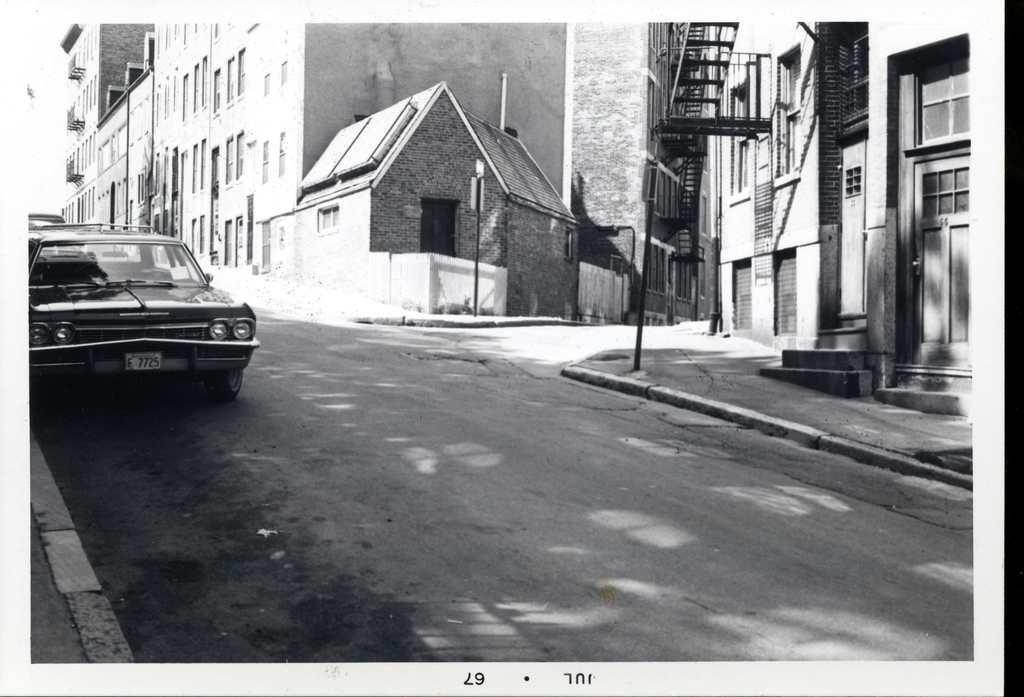Can you describe this image briefly? In this image there are buildings truncated towards the top of the image, there are windows, there is the door, there is the road truncated towards the bottom of the image, there are vehicles on the road, there is a pole, there are boards on the pole, there is a staircase truncated towards the top of the image, there are numbers and text. 